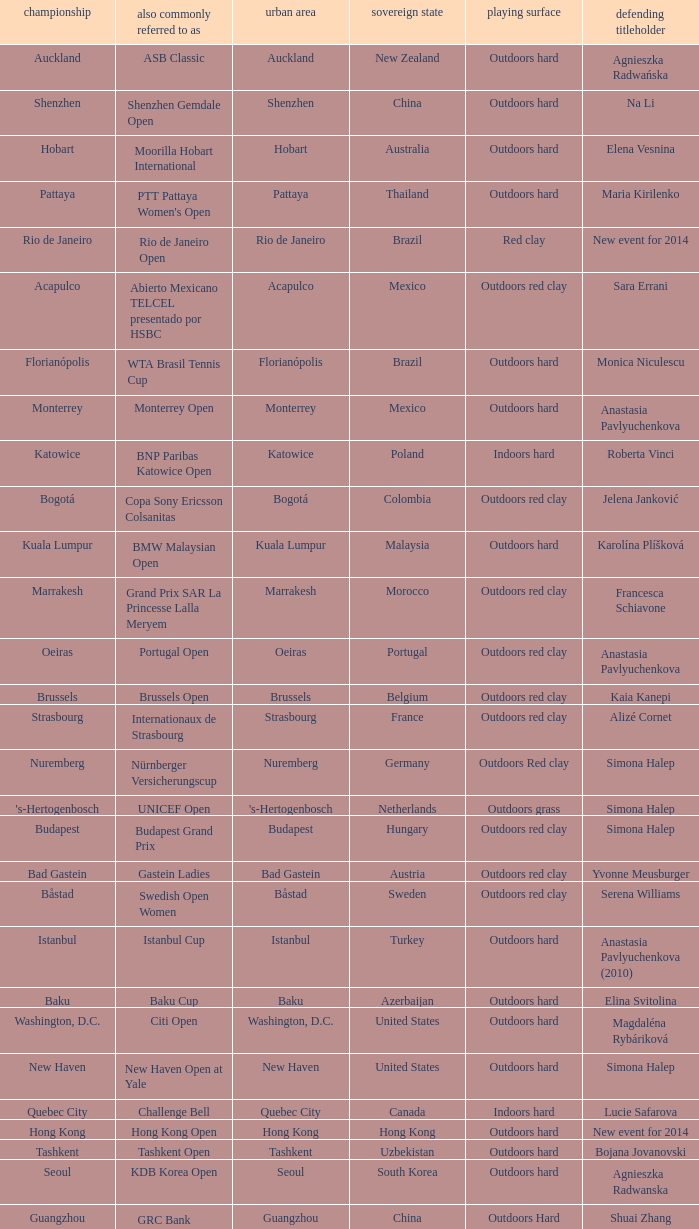What tournament is in katowice? Katowice. Can you give me this table as a dict? {'header': ['championship', 'also commonly referred to as', 'urban area', 'sovereign state', 'playing surface', 'defending titleholder'], 'rows': [['Auckland', 'ASB Classic', 'Auckland', 'New Zealand', 'Outdoors hard', 'Agnieszka Radwańska'], ['Shenzhen', 'Shenzhen Gemdale Open', 'Shenzhen', 'China', 'Outdoors hard', 'Na Li'], ['Hobart', 'Moorilla Hobart International', 'Hobart', 'Australia', 'Outdoors hard', 'Elena Vesnina'], ['Pattaya', "PTT Pattaya Women's Open", 'Pattaya', 'Thailand', 'Outdoors hard', 'Maria Kirilenko'], ['Rio de Janeiro', 'Rio de Janeiro Open', 'Rio de Janeiro', 'Brazil', 'Red clay', 'New event for 2014'], ['Acapulco', 'Abierto Mexicano TELCEL presentado por HSBC', 'Acapulco', 'Mexico', 'Outdoors red clay', 'Sara Errani'], ['Florianópolis', 'WTA Brasil Tennis Cup', 'Florianópolis', 'Brazil', 'Outdoors hard', 'Monica Niculescu'], ['Monterrey', 'Monterrey Open', 'Monterrey', 'Mexico', 'Outdoors hard', 'Anastasia Pavlyuchenkova'], ['Katowice', 'BNP Paribas Katowice Open', 'Katowice', 'Poland', 'Indoors hard', 'Roberta Vinci'], ['Bogotá', 'Copa Sony Ericsson Colsanitas', 'Bogotá', 'Colombia', 'Outdoors red clay', 'Jelena Janković'], ['Kuala Lumpur', 'BMW Malaysian Open', 'Kuala Lumpur', 'Malaysia', 'Outdoors hard', 'Karolína Plíšková'], ['Marrakesh', 'Grand Prix SAR La Princesse Lalla Meryem', 'Marrakesh', 'Morocco', 'Outdoors red clay', 'Francesca Schiavone'], ['Oeiras', 'Portugal Open', 'Oeiras', 'Portugal', 'Outdoors red clay', 'Anastasia Pavlyuchenkova'], ['Brussels', 'Brussels Open', 'Brussels', 'Belgium', 'Outdoors red clay', 'Kaia Kanepi'], ['Strasbourg', 'Internationaux de Strasbourg', 'Strasbourg', 'France', 'Outdoors red clay', 'Alizé Cornet'], ['Nuremberg', 'Nürnberger Versicherungscup', 'Nuremberg', 'Germany', 'Outdoors Red clay', 'Simona Halep'], ["'s-Hertogenbosch", 'UNICEF Open', "'s-Hertogenbosch", 'Netherlands', 'Outdoors grass', 'Simona Halep'], ['Budapest', 'Budapest Grand Prix', 'Budapest', 'Hungary', 'Outdoors red clay', 'Simona Halep'], ['Bad Gastein', 'Gastein Ladies', 'Bad Gastein', 'Austria', 'Outdoors red clay', 'Yvonne Meusburger'], ['Båstad', 'Swedish Open Women', 'Båstad', 'Sweden', 'Outdoors red clay', 'Serena Williams'], ['Istanbul', 'Istanbul Cup', 'Istanbul', 'Turkey', 'Outdoors hard', 'Anastasia Pavlyuchenkova (2010)'], ['Baku', 'Baku Cup', 'Baku', 'Azerbaijan', 'Outdoors hard', 'Elina Svitolina'], ['Washington, D.C.', 'Citi Open', 'Washington, D.C.', 'United States', 'Outdoors hard', 'Magdaléna Rybáriková'], ['New Haven', 'New Haven Open at Yale', 'New Haven', 'United States', 'Outdoors hard', 'Simona Halep'], ['Quebec City', 'Challenge Bell', 'Quebec City', 'Canada', 'Indoors hard', 'Lucie Safarova'], ['Hong Kong', 'Hong Kong Open', 'Hong Kong', 'Hong Kong', 'Outdoors hard', 'New event for 2014'], ['Tashkent', 'Tashkent Open', 'Tashkent', 'Uzbekistan', 'Outdoors hard', 'Bojana Jovanovski'], ['Seoul', 'KDB Korea Open', 'Seoul', 'South Korea', 'Outdoors hard', 'Agnieszka Radwanska'], ['Guangzhou', "GRC Bank Guangzhou International Women's Open", 'Guangzhou', 'China', 'Outdoors Hard', 'Shuai Zhang'], ['Linz', 'Generali Ladies Linz', 'Linz', 'Austria', 'Indoors hard', 'Angelique Kerber'], ['Osaka', 'HP Open', 'Osaka', 'Japan', 'Outdoors hard', 'Samantha Stosur'], ['Luxembourg', 'BGL Luxembourg Open', 'Luxembourg City', 'Luxembourg', 'Indoors hard', 'Caroline Wozniacki']]} 